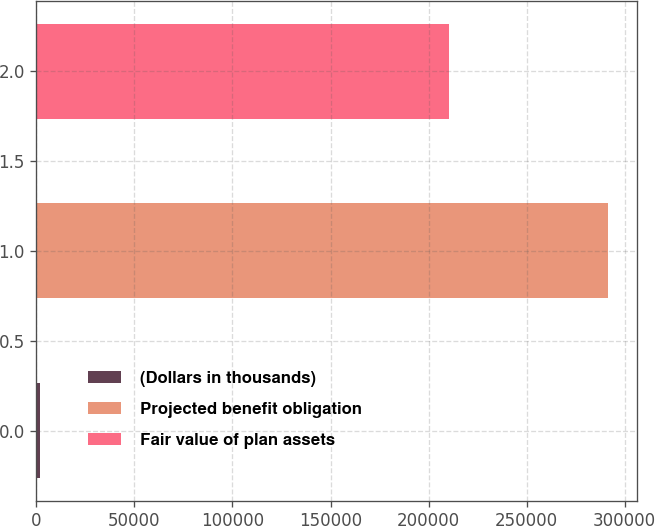<chart> <loc_0><loc_0><loc_500><loc_500><bar_chart><fcel>(Dollars in thousands)<fcel>Projected benefit obligation<fcel>Fair value of plan assets<nl><fcel>2017<fcel>291720<fcel>210267<nl></chart> 